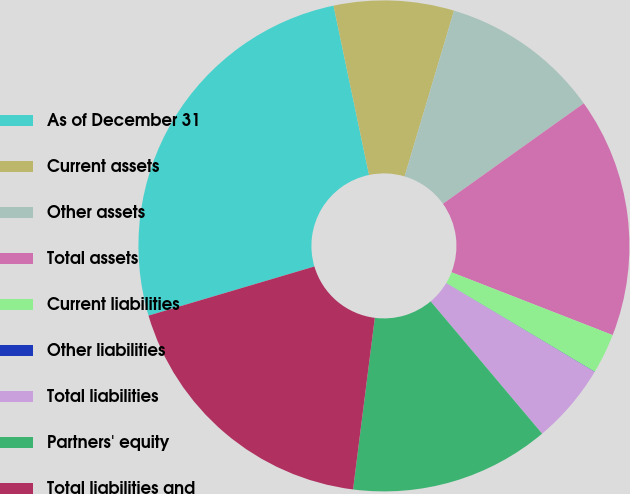Convert chart to OTSL. <chart><loc_0><loc_0><loc_500><loc_500><pie_chart><fcel>As of December 31<fcel>Current assets<fcel>Other assets<fcel>Total assets<fcel>Current liabilities<fcel>Other liabilities<fcel>Total liabilities<fcel>Partners' equity<fcel>Total liabilities and<nl><fcel>26.29%<fcel>7.9%<fcel>10.53%<fcel>15.78%<fcel>2.65%<fcel>0.02%<fcel>5.27%<fcel>13.15%<fcel>18.41%<nl></chart> 